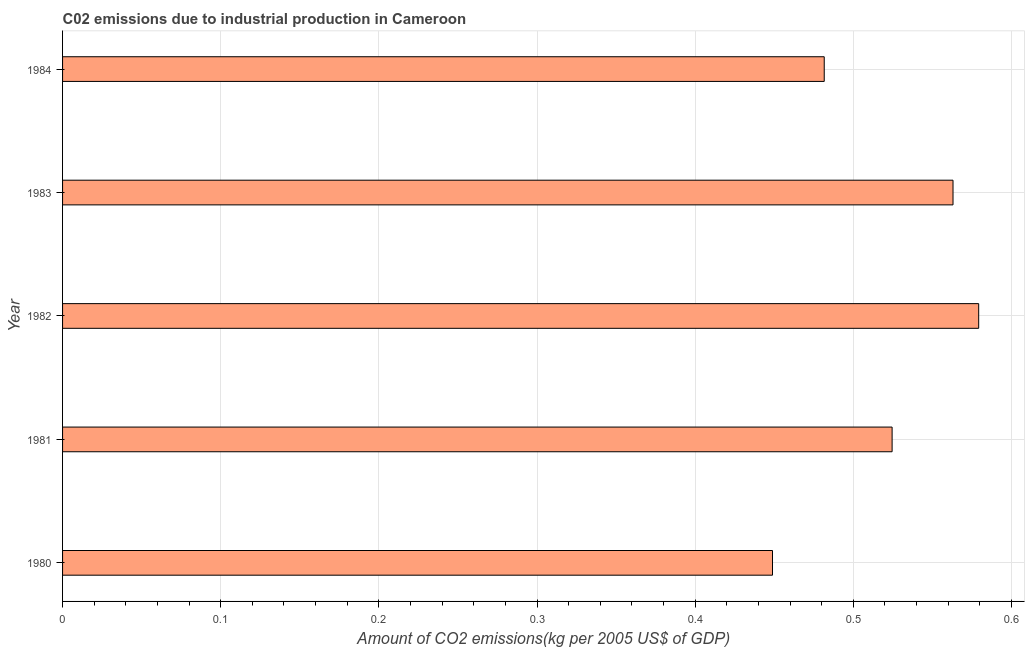Does the graph contain any zero values?
Offer a very short reply. No. What is the title of the graph?
Provide a succinct answer. C02 emissions due to industrial production in Cameroon. What is the label or title of the X-axis?
Provide a succinct answer. Amount of CO2 emissions(kg per 2005 US$ of GDP). What is the label or title of the Y-axis?
Keep it short and to the point. Year. What is the amount of co2 emissions in 1980?
Provide a succinct answer. 0.45. Across all years, what is the maximum amount of co2 emissions?
Provide a succinct answer. 0.58. Across all years, what is the minimum amount of co2 emissions?
Provide a short and direct response. 0.45. In which year was the amount of co2 emissions maximum?
Offer a terse response. 1982. In which year was the amount of co2 emissions minimum?
Offer a terse response. 1980. What is the sum of the amount of co2 emissions?
Your answer should be compact. 2.6. What is the difference between the amount of co2 emissions in 1980 and 1981?
Provide a short and direct response. -0.08. What is the average amount of co2 emissions per year?
Your answer should be compact. 0.52. What is the median amount of co2 emissions?
Ensure brevity in your answer.  0.52. What is the ratio of the amount of co2 emissions in 1983 to that in 1984?
Give a very brief answer. 1.17. Is the amount of co2 emissions in 1981 less than that in 1984?
Keep it short and to the point. No. What is the difference between the highest and the second highest amount of co2 emissions?
Your answer should be compact. 0.02. What is the difference between the highest and the lowest amount of co2 emissions?
Provide a short and direct response. 0.13. Are all the bars in the graph horizontal?
Your answer should be compact. Yes. Are the values on the major ticks of X-axis written in scientific E-notation?
Offer a very short reply. No. What is the Amount of CO2 emissions(kg per 2005 US$ of GDP) of 1980?
Offer a very short reply. 0.45. What is the Amount of CO2 emissions(kg per 2005 US$ of GDP) of 1981?
Provide a short and direct response. 0.52. What is the Amount of CO2 emissions(kg per 2005 US$ of GDP) of 1982?
Offer a terse response. 0.58. What is the Amount of CO2 emissions(kg per 2005 US$ of GDP) in 1983?
Offer a very short reply. 0.56. What is the Amount of CO2 emissions(kg per 2005 US$ of GDP) in 1984?
Provide a short and direct response. 0.48. What is the difference between the Amount of CO2 emissions(kg per 2005 US$ of GDP) in 1980 and 1981?
Your answer should be compact. -0.08. What is the difference between the Amount of CO2 emissions(kg per 2005 US$ of GDP) in 1980 and 1982?
Your response must be concise. -0.13. What is the difference between the Amount of CO2 emissions(kg per 2005 US$ of GDP) in 1980 and 1983?
Provide a succinct answer. -0.11. What is the difference between the Amount of CO2 emissions(kg per 2005 US$ of GDP) in 1980 and 1984?
Ensure brevity in your answer.  -0.03. What is the difference between the Amount of CO2 emissions(kg per 2005 US$ of GDP) in 1981 and 1982?
Provide a short and direct response. -0.05. What is the difference between the Amount of CO2 emissions(kg per 2005 US$ of GDP) in 1981 and 1983?
Ensure brevity in your answer.  -0.04. What is the difference between the Amount of CO2 emissions(kg per 2005 US$ of GDP) in 1981 and 1984?
Your answer should be very brief. 0.04. What is the difference between the Amount of CO2 emissions(kg per 2005 US$ of GDP) in 1982 and 1983?
Your answer should be compact. 0.02. What is the difference between the Amount of CO2 emissions(kg per 2005 US$ of GDP) in 1982 and 1984?
Offer a terse response. 0.1. What is the difference between the Amount of CO2 emissions(kg per 2005 US$ of GDP) in 1983 and 1984?
Offer a terse response. 0.08. What is the ratio of the Amount of CO2 emissions(kg per 2005 US$ of GDP) in 1980 to that in 1981?
Your answer should be compact. 0.86. What is the ratio of the Amount of CO2 emissions(kg per 2005 US$ of GDP) in 1980 to that in 1982?
Your answer should be compact. 0.78. What is the ratio of the Amount of CO2 emissions(kg per 2005 US$ of GDP) in 1980 to that in 1983?
Your answer should be compact. 0.8. What is the ratio of the Amount of CO2 emissions(kg per 2005 US$ of GDP) in 1980 to that in 1984?
Provide a succinct answer. 0.93. What is the ratio of the Amount of CO2 emissions(kg per 2005 US$ of GDP) in 1981 to that in 1982?
Provide a succinct answer. 0.91. What is the ratio of the Amount of CO2 emissions(kg per 2005 US$ of GDP) in 1981 to that in 1983?
Your answer should be very brief. 0.93. What is the ratio of the Amount of CO2 emissions(kg per 2005 US$ of GDP) in 1981 to that in 1984?
Provide a short and direct response. 1.09. What is the ratio of the Amount of CO2 emissions(kg per 2005 US$ of GDP) in 1982 to that in 1983?
Give a very brief answer. 1.03. What is the ratio of the Amount of CO2 emissions(kg per 2005 US$ of GDP) in 1982 to that in 1984?
Your answer should be very brief. 1.2. What is the ratio of the Amount of CO2 emissions(kg per 2005 US$ of GDP) in 1983 to that in 1984?
Provide a short and direct response. 1.17. 